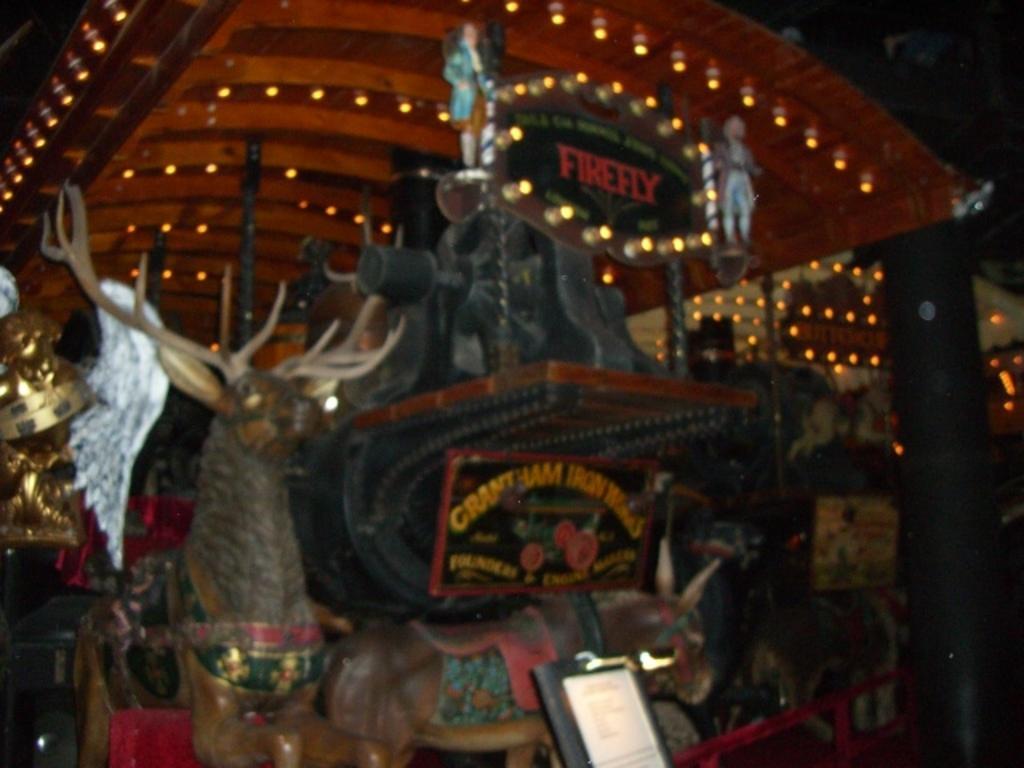Describe this image in one or two sentences. In this image I can see few toy dolls on the black color object. I can see few frames on it. Back I can see a brown color shade and lights. 